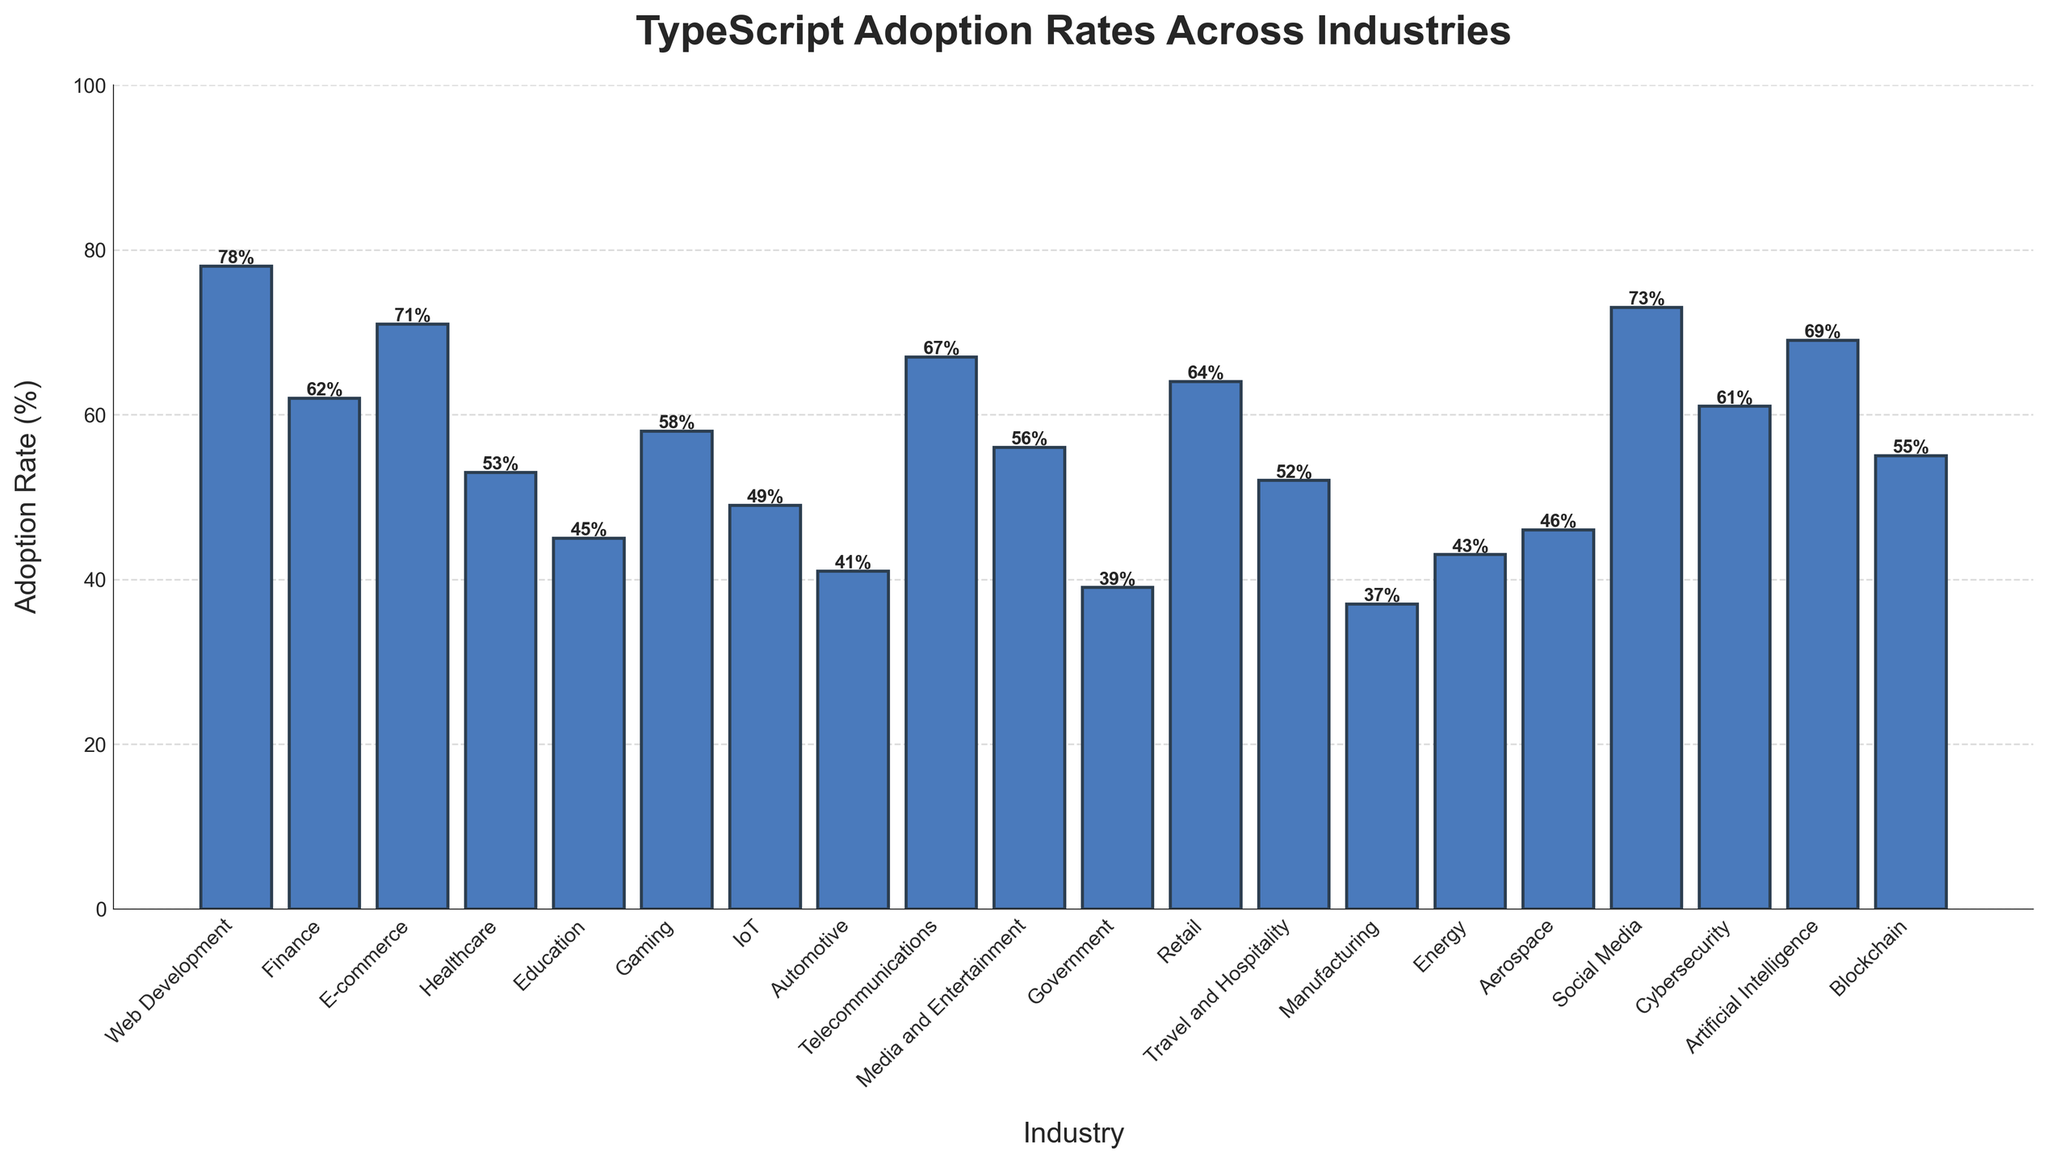Which industry has the highest TypeScript adoption rate? Examine the chart to identify the industry with the tallest bar. The tallest bar corresponds to Web Development with an adoption rate of 78%.
Answer: Web Development Which industry has the lowest TypeScript adoption rate? Look for the shortest bar on the chart. The shortest bar corresponds to Government with an adoption rate of 39%.
Answer: Government Compare the TypeScript adoption rates for Healthcare and Cybersecurity. Which industry has a higher rate? Identify the bars corresponding to Healthcare and Cybersecurity, then compare their heights. Healthcare has an adoption rate of 53% and Cybersecurity has an adoption rate of 61%. Cybersecurity's rate is higher.
Answer: Cybersecurity What is the difference in TypeScript adoption rates between Social Media and Retail? Locate the bars for Social Media and Retail and note their adoption rates. Calculate the difference: Social Media (73%) - Retail (64%) = 9%.
Answer: 9% What is the average TypeScript adoption rate across all listed industries? Sum the adoption rates for all industries and divide by the number of industries. The sum of the rates is 1042% for 20 industries: 1042 / 20 = 52.1%.
Answer: 52.1% Which two industries have the closest TypeScript adoption rates? Look for adjacent bars with nearly the same height. Telecommunications (67%) and E-commerce (71%) are close, but E-commerce (71%) and Artificial Intelligence (69%) are closer, with only a 2% difference.
Answer: E-commerce and Artificial Intelligence How does the adoption rate for Gaming compare to Education? Identify and compare the bars for Gaming and Education. Gaming has an adoption rate of 58% while Education has 45%. Hence, Gaming has a higher rate.
Answer: Gaming What is the total adoption rate percentage for the Finance, E-commerce, and Telecom industries combined? Add the adoption rates for Finance (62%), E-commerce (71%), and Telecom (67%): 62 + 71 + 67 = 200%.
Answer: 200% Which three industries have adoption rates above 70%? Identify bars taller than the 70% mark. These industries are Web Development (78%), Social Media (73%), and E-commerce (71%).
Answer: Web Development, Social Media, E-commerce Calculate the median adoption rate of the listed industries. Arrange the adoption rates in ascending order and find the middle value. With 20 industries, the median is the average of the 10th and 11th rates: (58% + 61%) / 2 = 59.5%.
Answer: 59.5% 